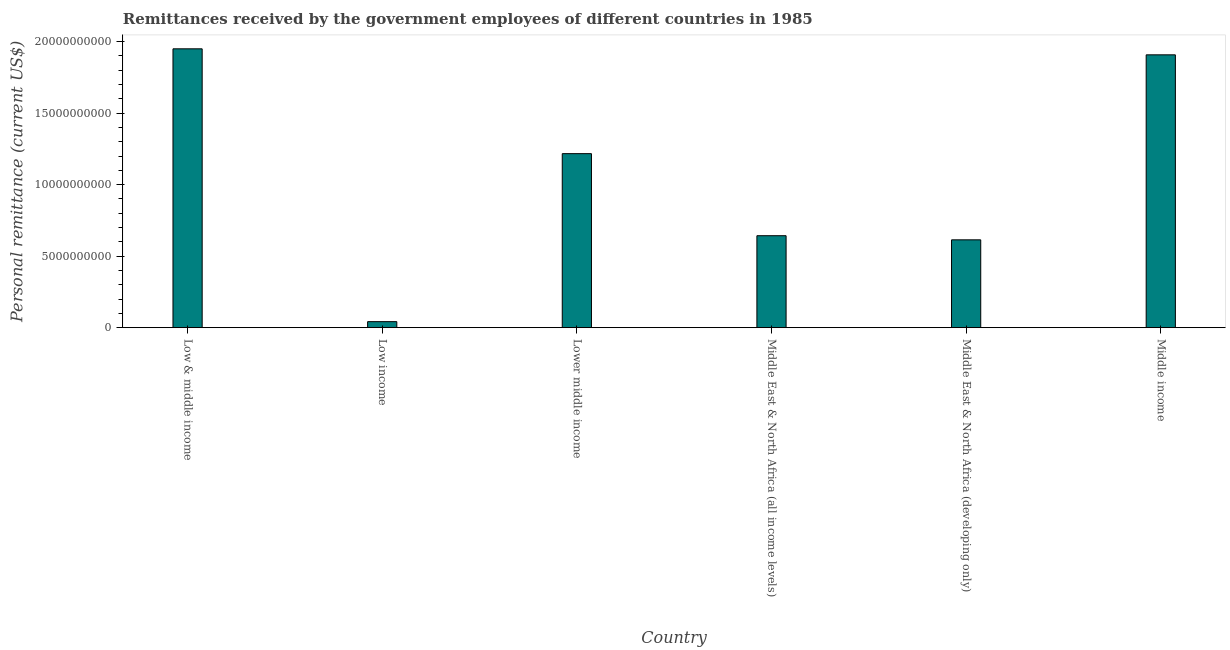Does the graph contain grids?
Your answer should be compact. No. What is the title of the graph?
Provide a succinct answer. Remittances received by the government employees of different countries in 1985. What is the label or title of the X-axis?
Offer a very short reply. Country. What is the label or title of the Y-axis?
Give a very brief answer. Personal remittance (current US$). What is the personal remittances in Middle income?
Ensure brevity in your answer.  1.91e+1. Across all countries, what is the maximum personal remittances?
Offer a very short reply. 1.95e+1. Across all countries, what is the minimum personal remittances?
Keep it short and to the point. 4.21e+08. In which country was the personal remittances minimum?
Keep it short and to the point. Low income. What is the sum of the personal remittances?
Keep it short and to the point. 6.37e+1. What is the difference between the personal remittances in Middle East & North Africa (all income levels) and Middle East & North Africa (developing only)?
Provide a succinct answer. 2.88e+08. What is the average personal remittances per country?
Ensure brevity in your answer.  1.06e+1. What is the median personal remittances?
Your answer should be very brief. 9.30e+09. In how many countries, is the personal remittances greater than 17000000000 US$?
Ensure brevity in your answer.  2. What is the ratio of the personal remittances in Lower middle income to that in Middle East & North Africa (all income levels)?
Offer a very short reply. 1.89. What is the difference between the highest and the second highest personal remittances?
Your answer should be compact. 4.21e+08. What is the difference between the highest and the lowest personal remittances?
Ensure brevity in your answer.  1.91e+1. How many bars are there?
Offer a terse response. 6. How many countries are there in the graph?
Offer a terse response. 6. What is the difference between two consecutive major ticks on the Y-axis?
Make the answer very short. 5.00e+09. What is the Personal remittance (current US$) of Low & middle income?
Your answer should be compact. 1.95e+1. What is the Personal remittance (current US$) of Low income?
Offer a terse response. 4.21e+08. What is the Personal remittance (current US$) of Lower middle income?
Offer a very short reply. 1.22e+1. What is the Personal remittance (current US$) in Middle East & North Africa (all income levels)?
Make the answer very short. 6.43e+09. What is the Personal remittance (current US$) of Middle East & North Africa (developing only)?
Provide a short and direct response. 6.14e+09. What is the Personal remittance (current US$) in Middle income?
Your answer should be very brief. 1.91e+1. What is the difference between the Personal remittance (current US$) in Low & middle income and Low income?
Give a very brief answer. 1.91e+1. What is the difference between the Personal remittance (current US$) in Low & middle income and Lower middle income?
Ensure brevity in your answer.  7.33e+09. What is the difference between the Personal remittance (current US$) in Low & middle income and Middle East & North Africa (all income levels)?
Provide a succinct answer. 1.31e+1. What is the difference between the Personal remittance (current US$) in Low & middle income and Middle East & North Africa (developing only)?
Your response must be concise. 1.34e+1. What is the difference between the Personal remittance (current US$) in Low & middle income and Middle income?
Provide a short and direct response. 4.21e+08. What is the difference between the Personal remittance (current US$) in Low income and Lower middle income?
Ensure brevity in your answer.  -1.17e+1. What is the difference between the Personal remittance (current US$) in Low income and Middle East & North Africa (all income levels)?
Provide a short and direct response. -6.01e+09. What is the difference between the Personal remittance (current US$) in Low income and Middle East & North Africa (developing only)?
Provide a succinct answer. -5.72e+09. What is the difference between the Personal remittance (current US$) in Low income and Middle income?
Provide a short and direct response. -1.87e+1. What is the difference between the Personal remittance (current US$) in Lower middle income and Middle East & North Africa (all income levels)?
Offer a very short reply. 5.74e+09. What is the difference between the Personal remittance (current US$) in Lower middle income and Middle East & North Africa (developing only)?
Ensure brevity in your answer.  6.02e+09. What is the difference between the Personal remittance (current US$) in Lower middle income and Middle income?
Make the answer very short. -6.91e+09. What is the difference between the Personal remittance (current US$) in Middle East & North Africa (all income levels) and Middle East & North Africa (developing only)?
Make the answer very short. 2.88e+08. What is the difference between the Personal remittance (current US$) in Middle East & North Africa (all income levels) and Middle income?
Your response must be concise. -1.26e+1. What is the difference between the Personal remittance (current US$) in Middle East & North Africa (developing only) and Middle income?
Offer a very short reply. -1.29e+1. What is the ratio of the Personal remittance (current US$) in Low & middle income to that in Low income?
Provide a succinct answer. 46.33. What is the ratio of the Personal remittance (current US$) in Low & middle income to that in Lower middle income?
Offer a terse response. 1.6. What is the ratio of the Personal remittance (current US$) in Low & middle income to that in Middle East & North Africa (all income levels)?
Provide a short and direct response. 3.03. What is the ratio of the Personal remittance (current US$) in Low & middle income to that in Middle East & North Africa (developing only)?
Ensure brevity in your answer.  3.17. What is the ratio of the Personal remittance (current US$) in Low income to that in Lower middle income?
Offer a very short reply. 0.04. What is the ratio of the Personal remittance (current US$) in Low income to that in Middle East & North Africa (all income levels)?
Ensure brevity in your answer.  0.07. What is the ratio of the Personal remittance (current US$) in Low income to that in Middle East & North Africa (developing only)?
Offer a very short reply. 0.07. What is the ratio of the Personal remittance (current US$) in Low income to that in Middle income?
Provide a short and direct response. 0.02. What is the ratio of the Personal remittance (current US$) in Lower middle income to that in Middle East & North Africa (all income levels)?
Provide a short and direct response. 1.89. What is the ratio of the Personal remittance (current US$) in Lower middle income to that in Middle East & North Africa (developing only)?
Offer a terse response. 1.98. What is the ratio of the Personal remittance (current US$) in Lower middle income to that in Middle income?
Keep it short and to the point. 0.64. What is the ratio of the Personal remittance (current US$) in Middle East & North Africa (all income levels) to that in Middle East & North Africa (developing only)?
Keep it short and to the point. 1.05. What is the ratio of the Personal remittance (current US$) in Middle East & North Africa (all income levels) to that in Middle income?
Provide a short and direct response. 0.34. What is the ratio of the Personal remittance (current US$) in Middle East & North Africa (developing only) to that in Middle income?
Provide a succinct answer. 0.32. 